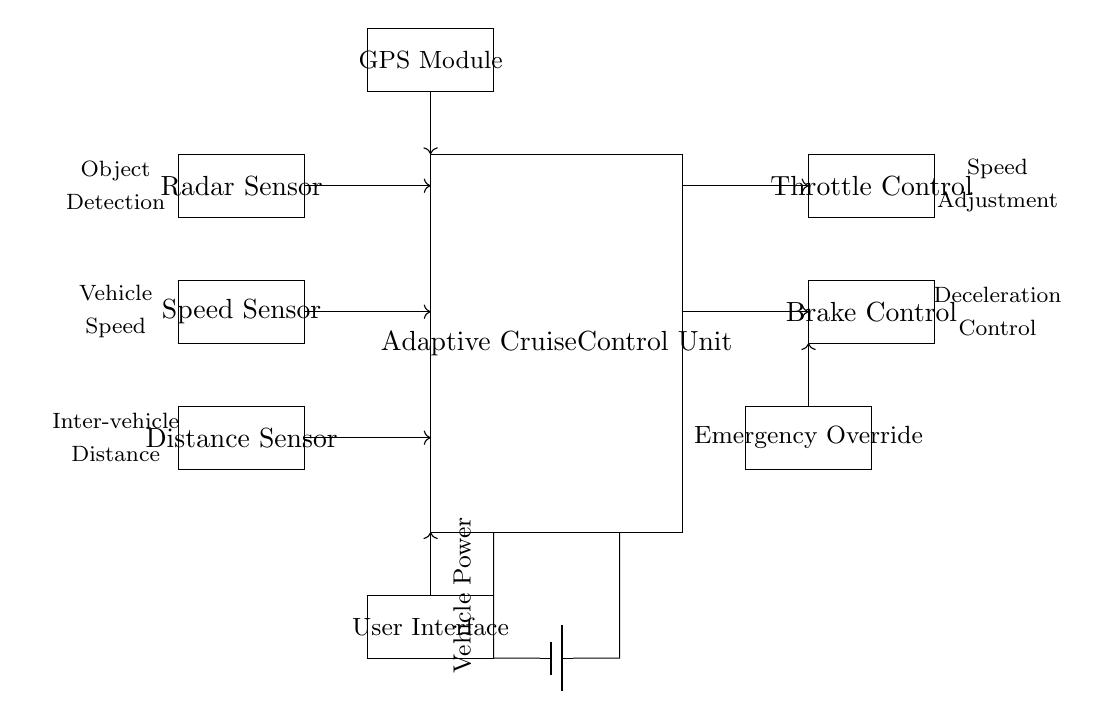What are the main components of this adaptive cruise control circuit? The main components include the Adaptive Cruise Control Unit, Radar Sensor, Speed Sensor, Distance Sensor, Throttle Control, Brake Control, User Interface, Emergency Override, and GPS Module.
Answer: Adaptive Cruise Control Unit, Radar Sensor, Speed Sensor, Distance Sensor, Throttle Control, Brake Control, User Interface, Emergency Override, GPS Module What type of sensors are used in this circuit? The circuit uses three types of sensors: Radar Sensor, Speed Sensor, and Distance Sensor, each serving specific functions in measuring different aspects of vehicle operation and surroundings.
Answer: Radar Sensor, Speed Sensor, Distance Sensor What is the purpose of the Throttle Control in this circuit? Throttle Control is designed to manage the acceleration of the vehicle by adjusting the throttle based on inputs from other components, specifically to maintain the desired speed when using adaptive cruise control.
Answer: Manage acceleration How many sensors interface directly with the Adaptive Cruise Control Unit? There are three sensors that interface directly with the Adaptive Cruise Control Unit: Radar Sensor, Speed Sensor, and Distance Sensor, indicated by the arrows showing connections.
Answer: Three What function does the Emergency Override serve in this adaptive cruise control circuit? The Emergency Override allows the driver to regain manual control of the vehicle when needed, ensuring safety and responsiveness in critical situations.
Answer: Regain manual control How does the User Interface connect to the Adaptive Cruise Control Unit? The User Interface connects to the Adaptive Cruise Control Unit with a directed arrow indicating data flow, allowing the driver to input commands and settings for the cruise control function.
Answer: Directed arrow 